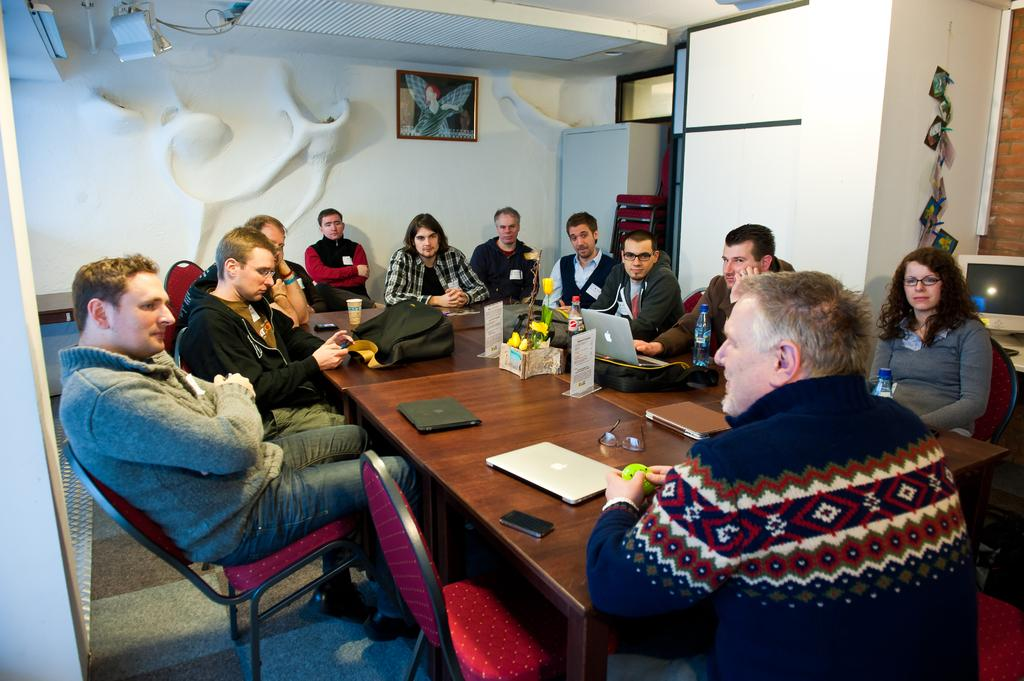How many people are in the image? There is a group of people in the image. What are the people doing in the image? The people are sitting around a table. What electronic devices are on the table? There are laptops, backpacks, and phones on the table. What type of song is being played on the dime in the image? There is no dime or song present in the image. 